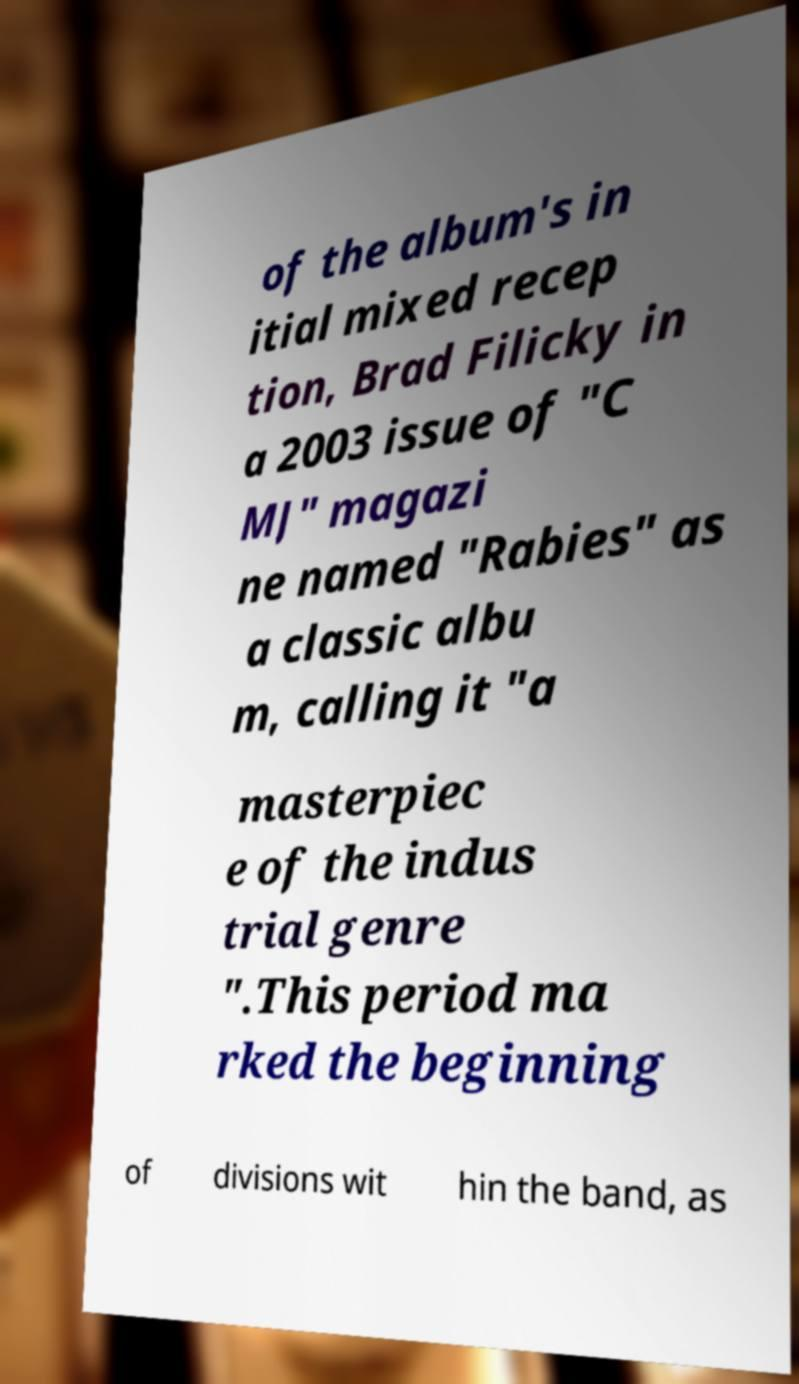For documentation purposes, I need the text within this image transcribed. Could you provide that? of the album's in itial mixed recep tion, Brad Filicky in a 2003 issue of "C MJ" magazi ne named "Rabies" as a classic albu m, calling it "a masterpiec e of the indus trial genre ".This period ma rked the beginning of divisions wit hin the band, as 